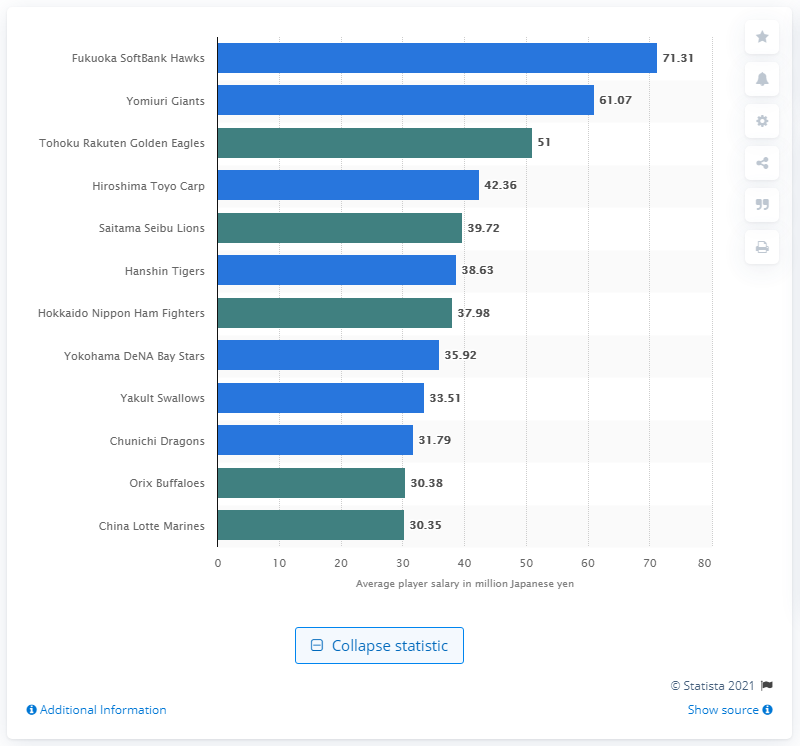Specify some key components in this picture. The average salary of players on the Fukuoka SoftBank Hawks baseball team in Japan in 2020 was 71.31. The Yomiuri Giants received the highest remuneration among all teams in Japan. 